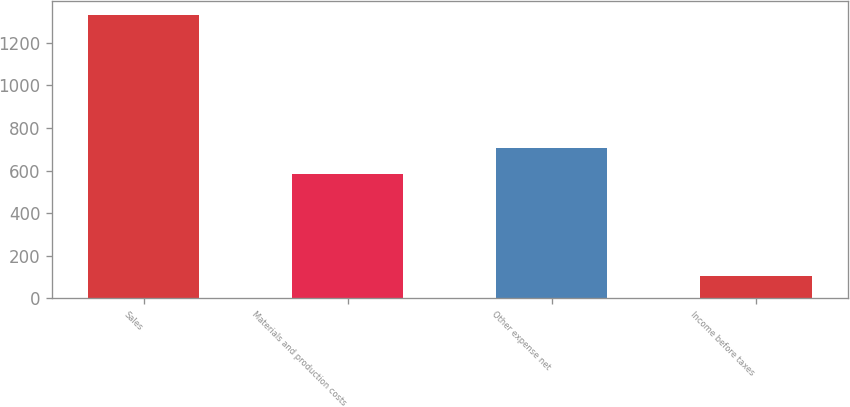<chart> <loc_0><loc_0><loc_500><loc_500><bar_chart><fcel>Sales<fcel>Materials and production costs<fcel>Other expense net<fcel>Income before taxes<nl><fcel>1331<fcel>584<fcel>706.6<fcel>105<nl></chart> 